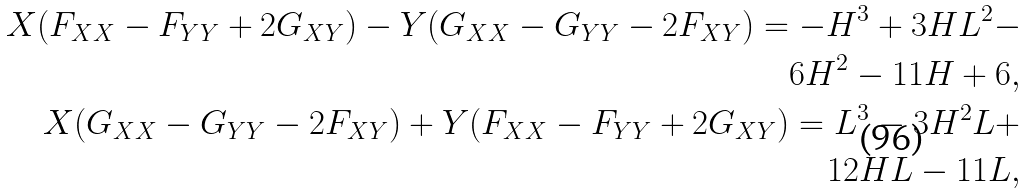<formula> <loc_0><loc_0><loc_500><loc_500>X ( F _ { X X } - F _ { Y Y } + 2 G _ { X Y } ) - Y ( G _ { X X } - G _ { Y Y } - 2 F _ { X Y } ) = - H ^ { 3 } + 3 H L ^ { 2 } - \\ \text { \quad } 6 H ^ { 2 } - 1 1 H + 6 , \\ X ( G _ { X X } - G _ { Y Y } - 2 F _ { X Y } ) + Y ( F _ { X X } - F _ { Y Y } + 2 G _ { X Y } ) = L ^ { 3 } - 3 H ^ { 2 } L + \\ \text { \quad \ \ } 1 2 H L - 1 1 L ,</formula> 